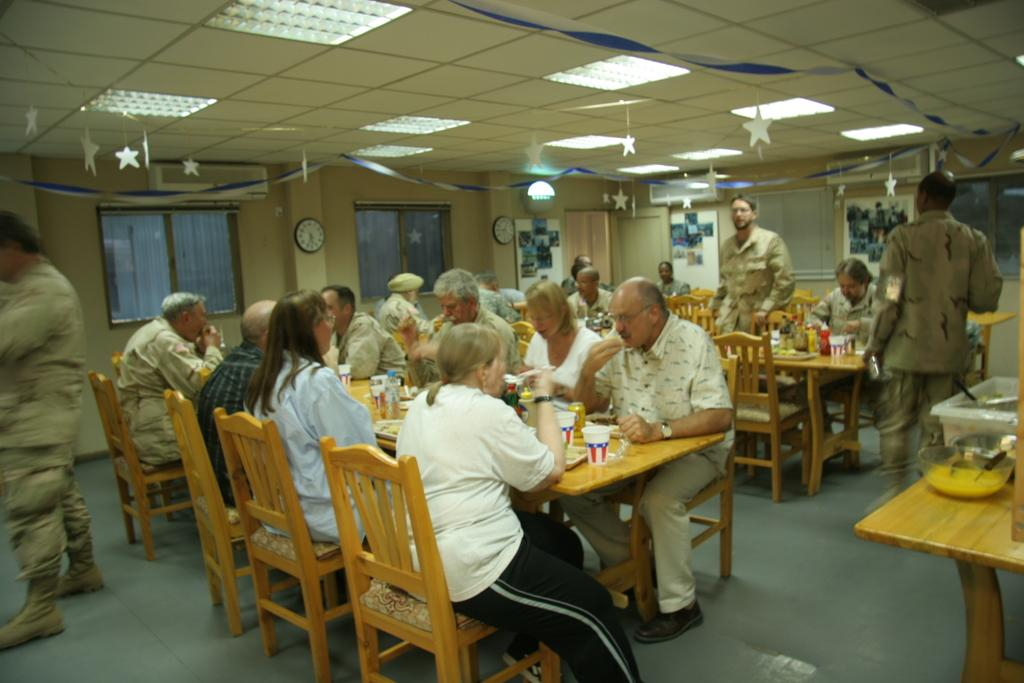What are the people in the image doing? The people in the image are sitting on chairs. What is present in the image besides the people sitting on chairs? There is a table in the image. What can be found on the table? There is a glass and food items on a plate on the table. Are there any people standing in the image? Yes, there are people standing in the image. What type of fuel is being used by the sheep in the image? There are no sheep present in the image. 